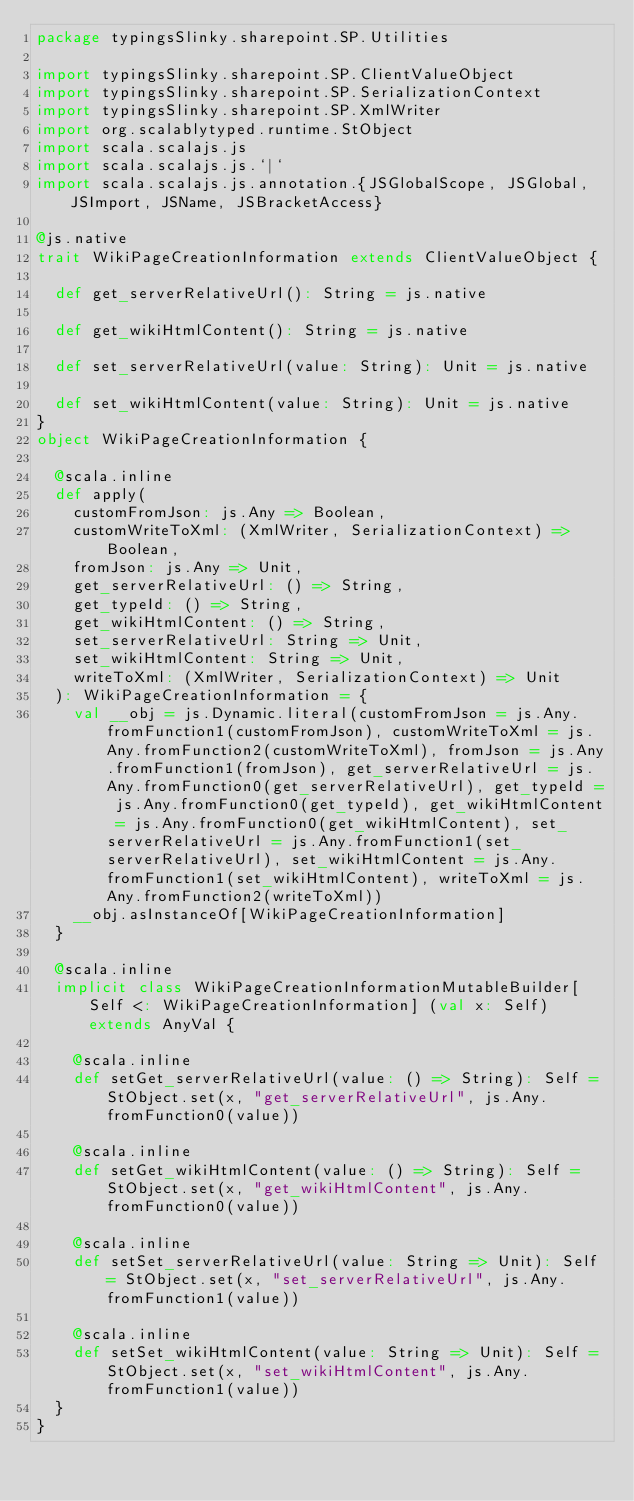Convert code to text. <code><loc_0><loc_0><loc_500><loc_500><_Scala_>package typingsSlinky.sharepoint.SP.Utilities

import typingsSlinky.sharepoint.SP.ClientValueObject
import typingsSlinky.sharepoint.SP.SerializationContext
import typingsSlinky.sharepoint.SP.XmlWriter
import org.scalablytyped.runtime.StObject
import scala.scalajs.js
import scala.scalajs.js.`|`
import scala.scalajs.js.annotation.{JSGlobalScope, JSGlobal, JSImport, JSName, JSBracketAccess}

@js.native
trait WikiPageCreationInformation extends ClientValueObject {
  
  def get_serverRelativeUrl(): String = js.native
  
  def get_wikiHtmlContent(): String = js.native
  
  def set_serverRelativeUrl(value: String): Unit = js.native
  
  def set_wikiHtmlContent(value: String): Unit = js.native
}
object WikiPageCreationInformation {
  
  @scala.inline
  def apply(
    customFromJson: js.Any => Boolean,
    customWriteToXml: (XmlWriter, SerializationContext) => Boolean,
    fromJson: js.Any => Unit,
    get_serverRelativeUrl: () => String,
    get_typeId: () => String,
    get_wikiHtmlContent: () => String,
    set_serverRelativeUrl: String => Unit,
    set_wikiHtmlContent: String => Unit,
    writeToXml: (XmlWriter, SerializationContext) => Unit
  ): WikiPageCreationInformation = {
    val __obj = js.Dynamic.literal(customFromJson = js.Any.fromFunction1(customFromJson), customWriteToXml = js.Any.fromFunction2(customWriteToXml), fromJson = js.Any.fromFunction1(fromJson), get_serverRelativeUrl = js.Any.fromFunction0(get_serverRelativeUrl), get_typeId = js.Any.fromFunction0(get_typeId), get_wikiHtmlContent = js.Any.fromFunction0(get_wikiHtmlContent), set_serverRelativeUrl = js.Any.fromFunction1(set_serverRelativeUrl), set_wikiHtmlContent = js.Any.fromFunction1(set_wikiHtmlContent), writeToXml = js.Any.fromFunction2(writeToXml))
    __obj.asInstanceOf[WikiPageCreationInformation]
  }
  
  @scala.inline
  implicit class WikiPageCreationInformationMutableBuilder[Self <: WikiPageCreationInformation] (val x: Self) extends AnyVal {
    
    @scala.inline
    def setGet_serverRelativeUrl(value: () => String): Self = StObject.set(x, "get_serverRelativeUrl", js.Any.fromFunction0(value))
    
    @scala.inline
    def setGet_wikiHtmlContent(value: () => String): Self = StObject.set(x, "get_wikiHtmlContent", js.Any.fromFunction0(value))
    
    @scala.inline
    def setSet_serverRelativeUrl(value: String => Unit): Self = StObject.set(x, "set_serverRelativeUrl", js.Any.fromFunction1(value))
    
    @scala.inline
    def setSet_wikiHtmlContent(value: String => Unit): Self = StObject.set(x, "set_wikiHtmlContent", js.Any.fromFunction1(value))
  }
}
</code> 